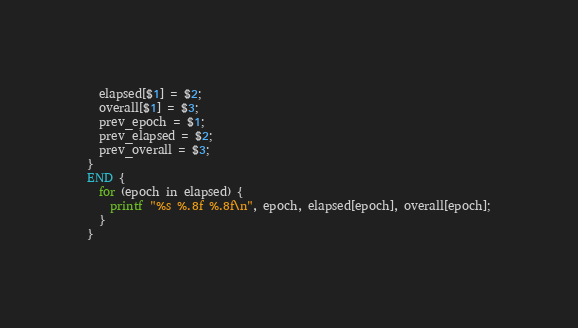<code> <loc_0><loc_0><loc_500><loc_500><_Awk_>  elapsed[$1] = $2;
  overall[$1] = $3;
  prev_epoch = $1;   
  prev_elapsed = $2;
  prev_overall = $3;
}
END {
  for (epoch in elapsed) {
    printf "%s %.8f %.8f\n", epoch, elapsed[epoch], overall[epoch];
  }
}
</code> 